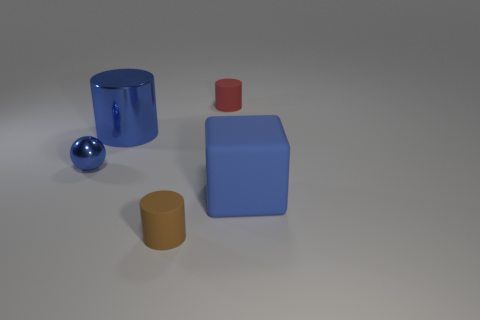Does the blue object that is in front of the blue sphere have the same shape as the red thing?
Provide a short and direct response. No. What number of cyan things are either big metal things or rubber cylinders?
Give a very brief answer. 0. Are there the same number of red matte cylinders in front of the red rubber object and large metallic cylinders in front of the large blue rubber cube?
Your answer should be very brief. Yes. The small rubber cylinder in front of the large blue thing that is behind the blue object to the right of the brown matte cylinder is what color?
Provide a succinct answer. Brown. Is there anything else of the same color as the small sphere?
Offer a very short reply. Yes. What is the shape of the big matte object that is the same color as the big shiny cylinder?
Your answer should be compact. Cube. There is a cylinder in front of the tiny shiny thing; what is its size?
Offer a very short reply. Small. There is a brown matte thing that is the same size as the blue sphere; what is its shape?
Your answer should be very brief. Cylinder. Are the blue thing to the left of the big cylinder and the cylinder to the right of the small brown rubber thing made of the same material?
Ensure brevity in your answer.  No. There is a tiny cylinder left of the cylinder behind the large blue metallic cylinder; what is it made of?
Your response must be concise. Rubber. 